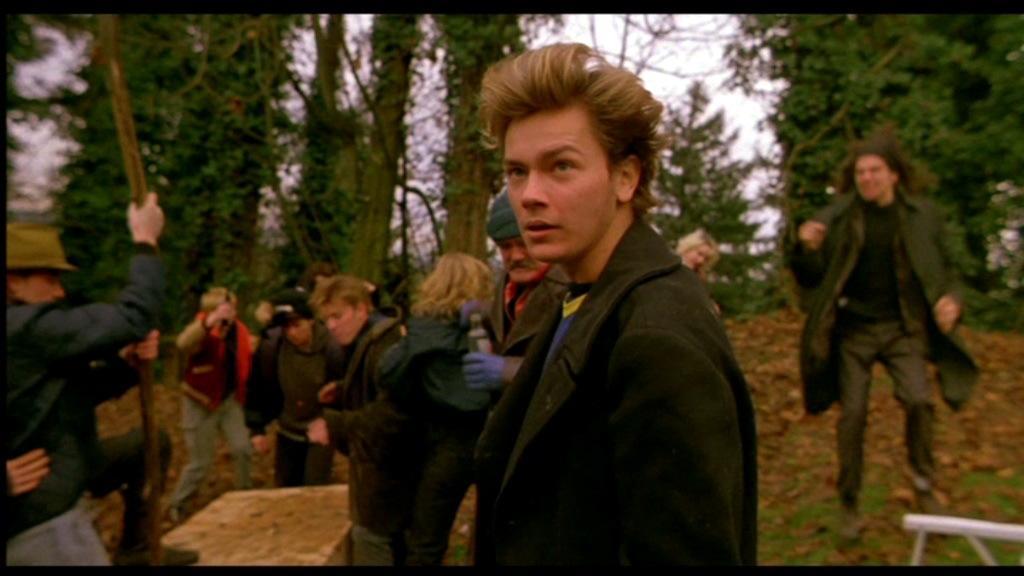How would you summarize this image in a sentence or two? This is a picture taken in a forest. In the foreground of the picture there is a man standing wearing a black suit, behind him there are many people. On the left there is a person holding stick. In the background there are trees, dry leaves. The background is blurred. 